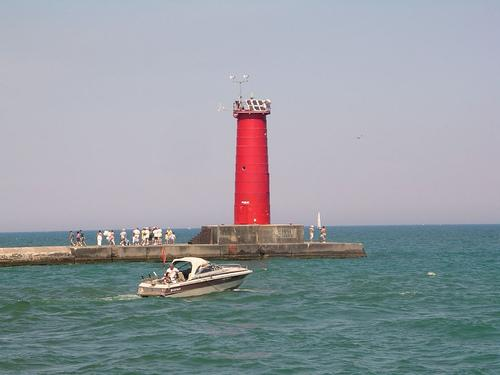How did the people standing near the lighthouse structure arrive here?

Choices:
A) uber
B) walking
C) by boat
D) lyft walking 